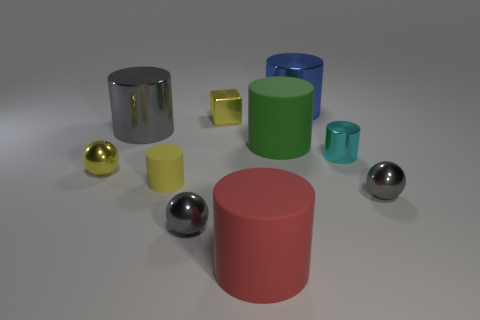Subtract all red cylinders. How many cylinders are left? 5 Subtract all large red cylinders. How many cylinders are left? 5 Subtract all red cylinders. Subtract all cyan cubes. How many cylinders are left? 5 Subtract all blocks. How many objects are left? 9 Add 5 small cyan things. How many small cyan things are left? 6 Add 4 small red balls. How many small red balls exist? 4 Subtract 0 cyan cubes. How many objects are left? 10 Subtract all gray metallic cylinders. Subtract all yellow cubes. How many objects are left? 8 